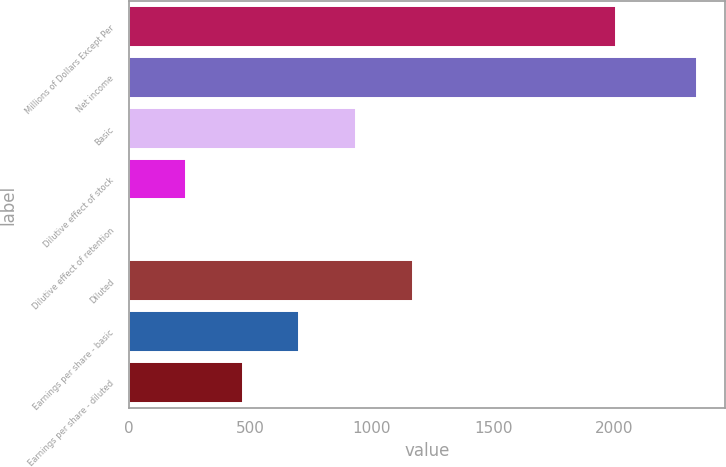<chart> <loc_0><loc_0><loc_500><loc_500><bar_chart><fcel>Millions of Dollars Except Per<fcel>Net income<fcel>Basic<fcel>Dilutive effect of stock<fcel>Dilutive effect of retention<fcel>Diluted<fcel>Earnings per share - basic<fcel>Earnings per share - diluted<nl><fcel>2008<fcel>2338<fcel>935.8<fcel>234.7<fcel>1<fcel>1169.5<fcel>702.1<fcel>468.4<nl></chart> 